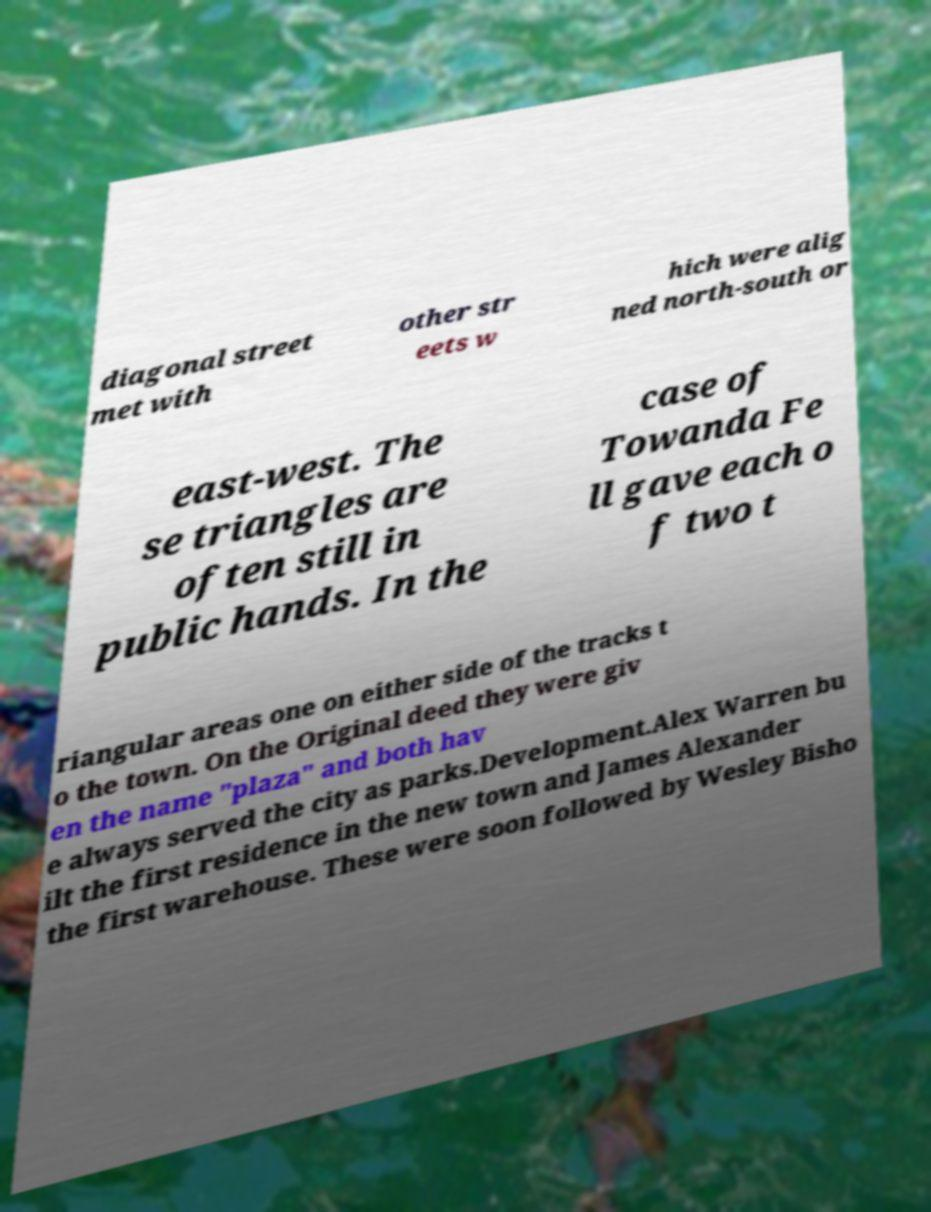What messages or text are displayed in this image? I need them in a readable, typed format. diagonal street met with other str eets w hich were alig ned north-south or east-west. The se triangles are often still in public hands. In the case of Towanda Fe ll gave each o f two t riangular areas one on either side of the tracks t o the town. On the Original deed they were giv en the name "plaza" and both hav e always served the city as parks.Development.Alex Warren bu ilt the first residence in the new town and James Alexander the first warehouse. These were soon followed by Wesley Bisho 